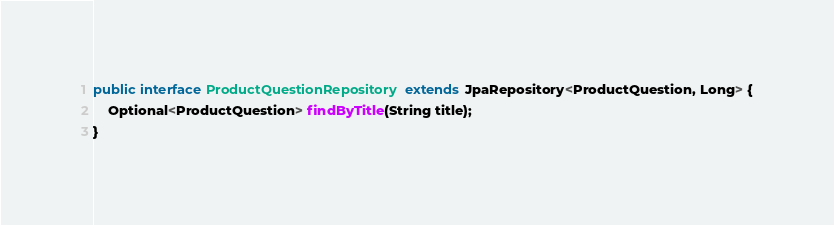Convert code to text. <code><loc_0><loc_0><loc_500><loc_500><_Java_>
public interface ProductQuestionRepository extends JpaRepository<ProductQuestion, Long> {
    Optional<ProductQuestion> findByTitle(String title);
}
</code> 